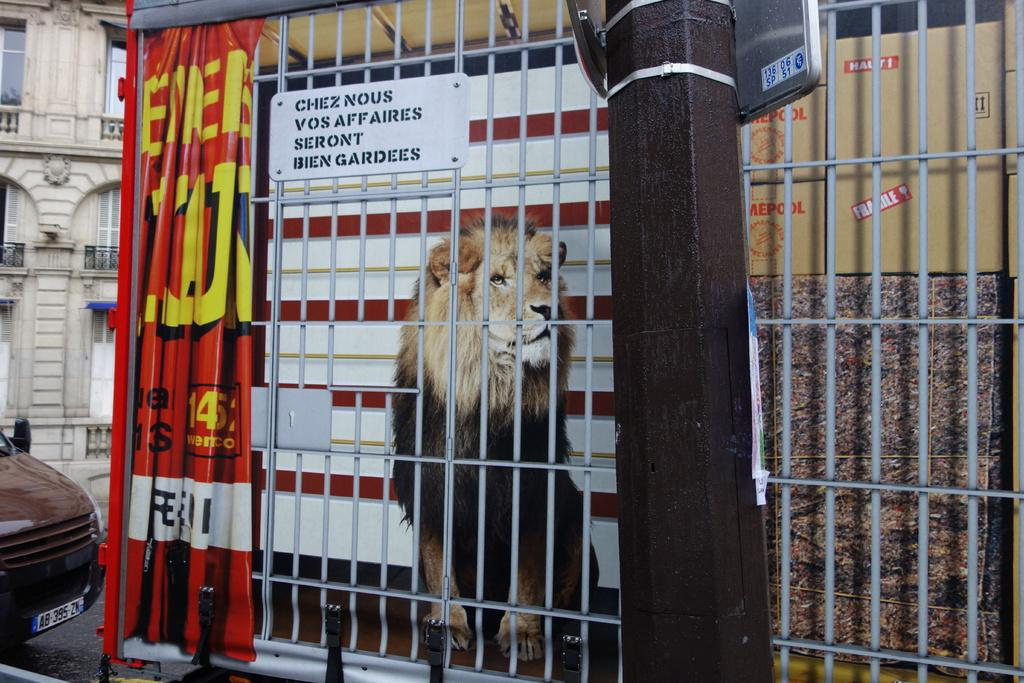What animal is present in the image? There is a lion in the image. What objects can be seen in the image besides the lion? There is a board, a banner, a pole, a carton box, a grill, a vehicle on the road, and a building in the image. What color is the orange that the lion is holding in the image? There is no orange present in the image; the lion is not holding any fruit or object. How many buttons can be seen on the lion's shirt in the image? There is no shirt or buttons visible in the image, as the lion is a wild animal and not dressed in clothing. 